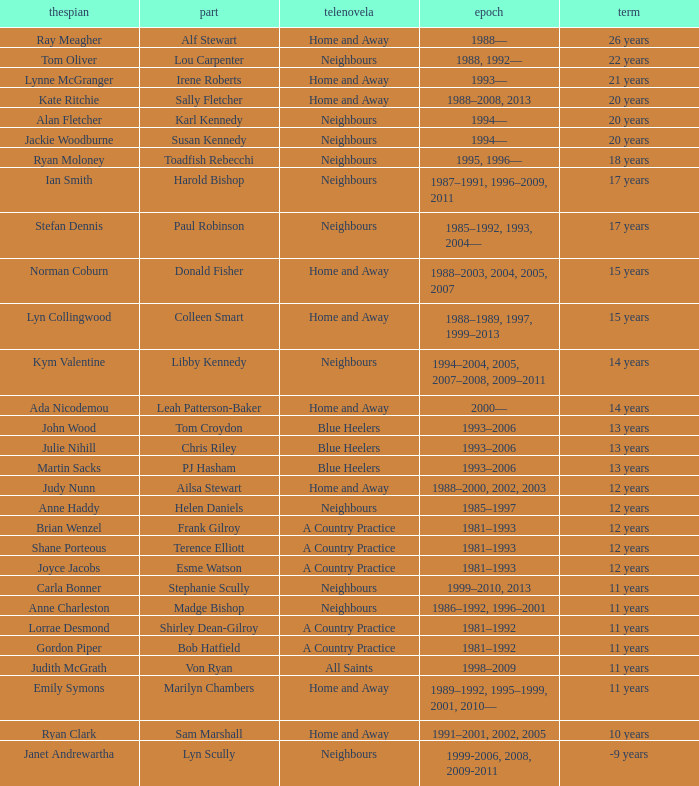Which performer portrayed harold bishop for 17 years? Ian Smith. 